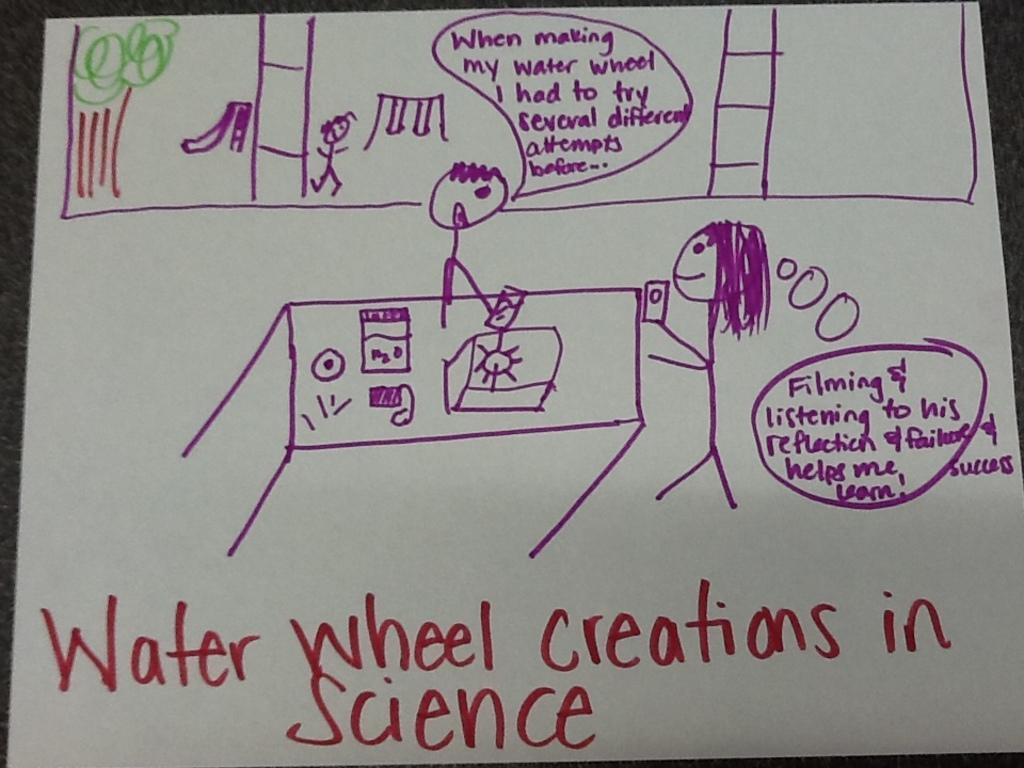How would you summarize this image in a sentence or two? In this image, we can see the drawing and some text on the white paper. 